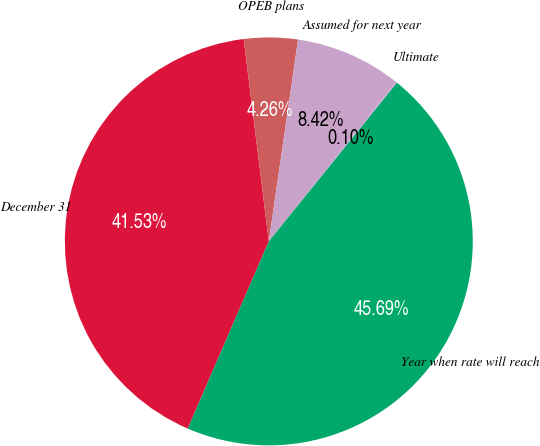<chart> <loc_0><loc_0><loc_500><loc_500><pie_chart><fcel>December 31<fcel>OPEB plans<fcel>Assumed for next year<fcel>Ultimate<fcel>Year when rate will reach<nl><fcel>41.53%<fcel>4.26%<fcel>8.42%<fcel>0.1%<fcel>45.69%<nl></chart> 